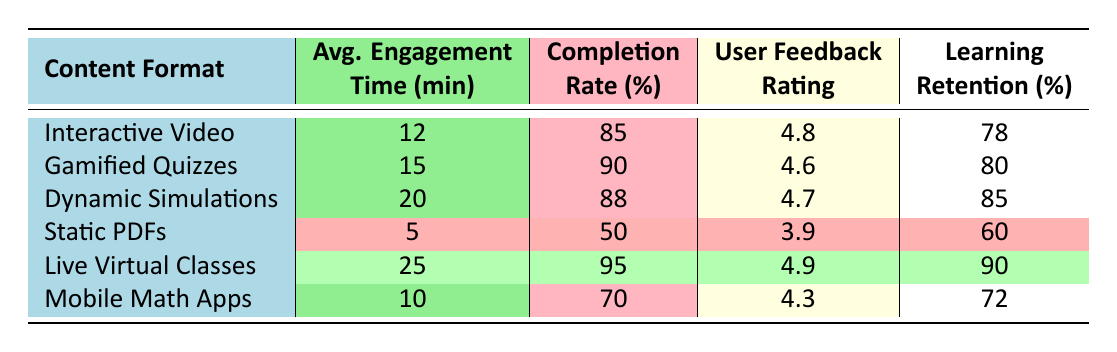What is the average engagement time for Dynamic Simulations? The table shows that the average engagement time for Dynamic Simulations is listed as 20 minutes.
Answer: 20 minutes What is the completion rate of Static PDFs? According to the table, the completion rate for Static PDFs is marked as 50%.
Answer: 50% Which content format has the highest user feedback rating? In the table, Live Virtual Classes has the highest user feedback rating at 4.9.
Answer: Live Virtual Classes What is the learning retention percentage for Gamified Quizzes? The table indicates that the learning retention percentage for Gamified Quizzes is 80%.
Answer: 80% What is the difference in average engagement time between Live Virtual Classes and Static PDFs? The average engagement time for Live Virtual Classes is 25 minutes while for Static PDFs it is 5 minutes. The difference is 25 - 5 = 20 minutes.
Answer: 20 minutes Which content format has the lowest completion rate? The table shows that Static PDFs have the lowest completion rate at 50%.
Answer: Static PDFs If you average the user feedback ratings of all formats, what is the approximate rating? To find the average, sum all the ratings (4.8 + 4.6 + 4.7 + 3.9 + 4.9 + 4.3 = 27.2) and divide by 6. Thus, 27.2 / 6 = approximately 4.53.
Answer: Approximately 4.53 Can you determine whether Dynamic Simulations have a higher learning retention percentage compared to Interactive Videos? The learning retention percentage for Dynamic Simulations is 85%, while for Interactive Videos it is 78%. Since 85% is greater than 78%, Dynamic Simulations do have a higher retention percentage.
Answer: Yes What is the average completion rate across all content formats? To find the average completion rate, sum all the completion rates (85 + 90 + 88 + 50 + 95 + 70 = 478) and divide by 6, which gives about 79.67%.
Answer: Approximately 79.67% Is the average engagement time for Mobile Math Apps more than 10 minutes? The table shows the average engagement time for Mobile Math Apps is 10 minutes, which is not more than 10 minutes.
Answer: No 